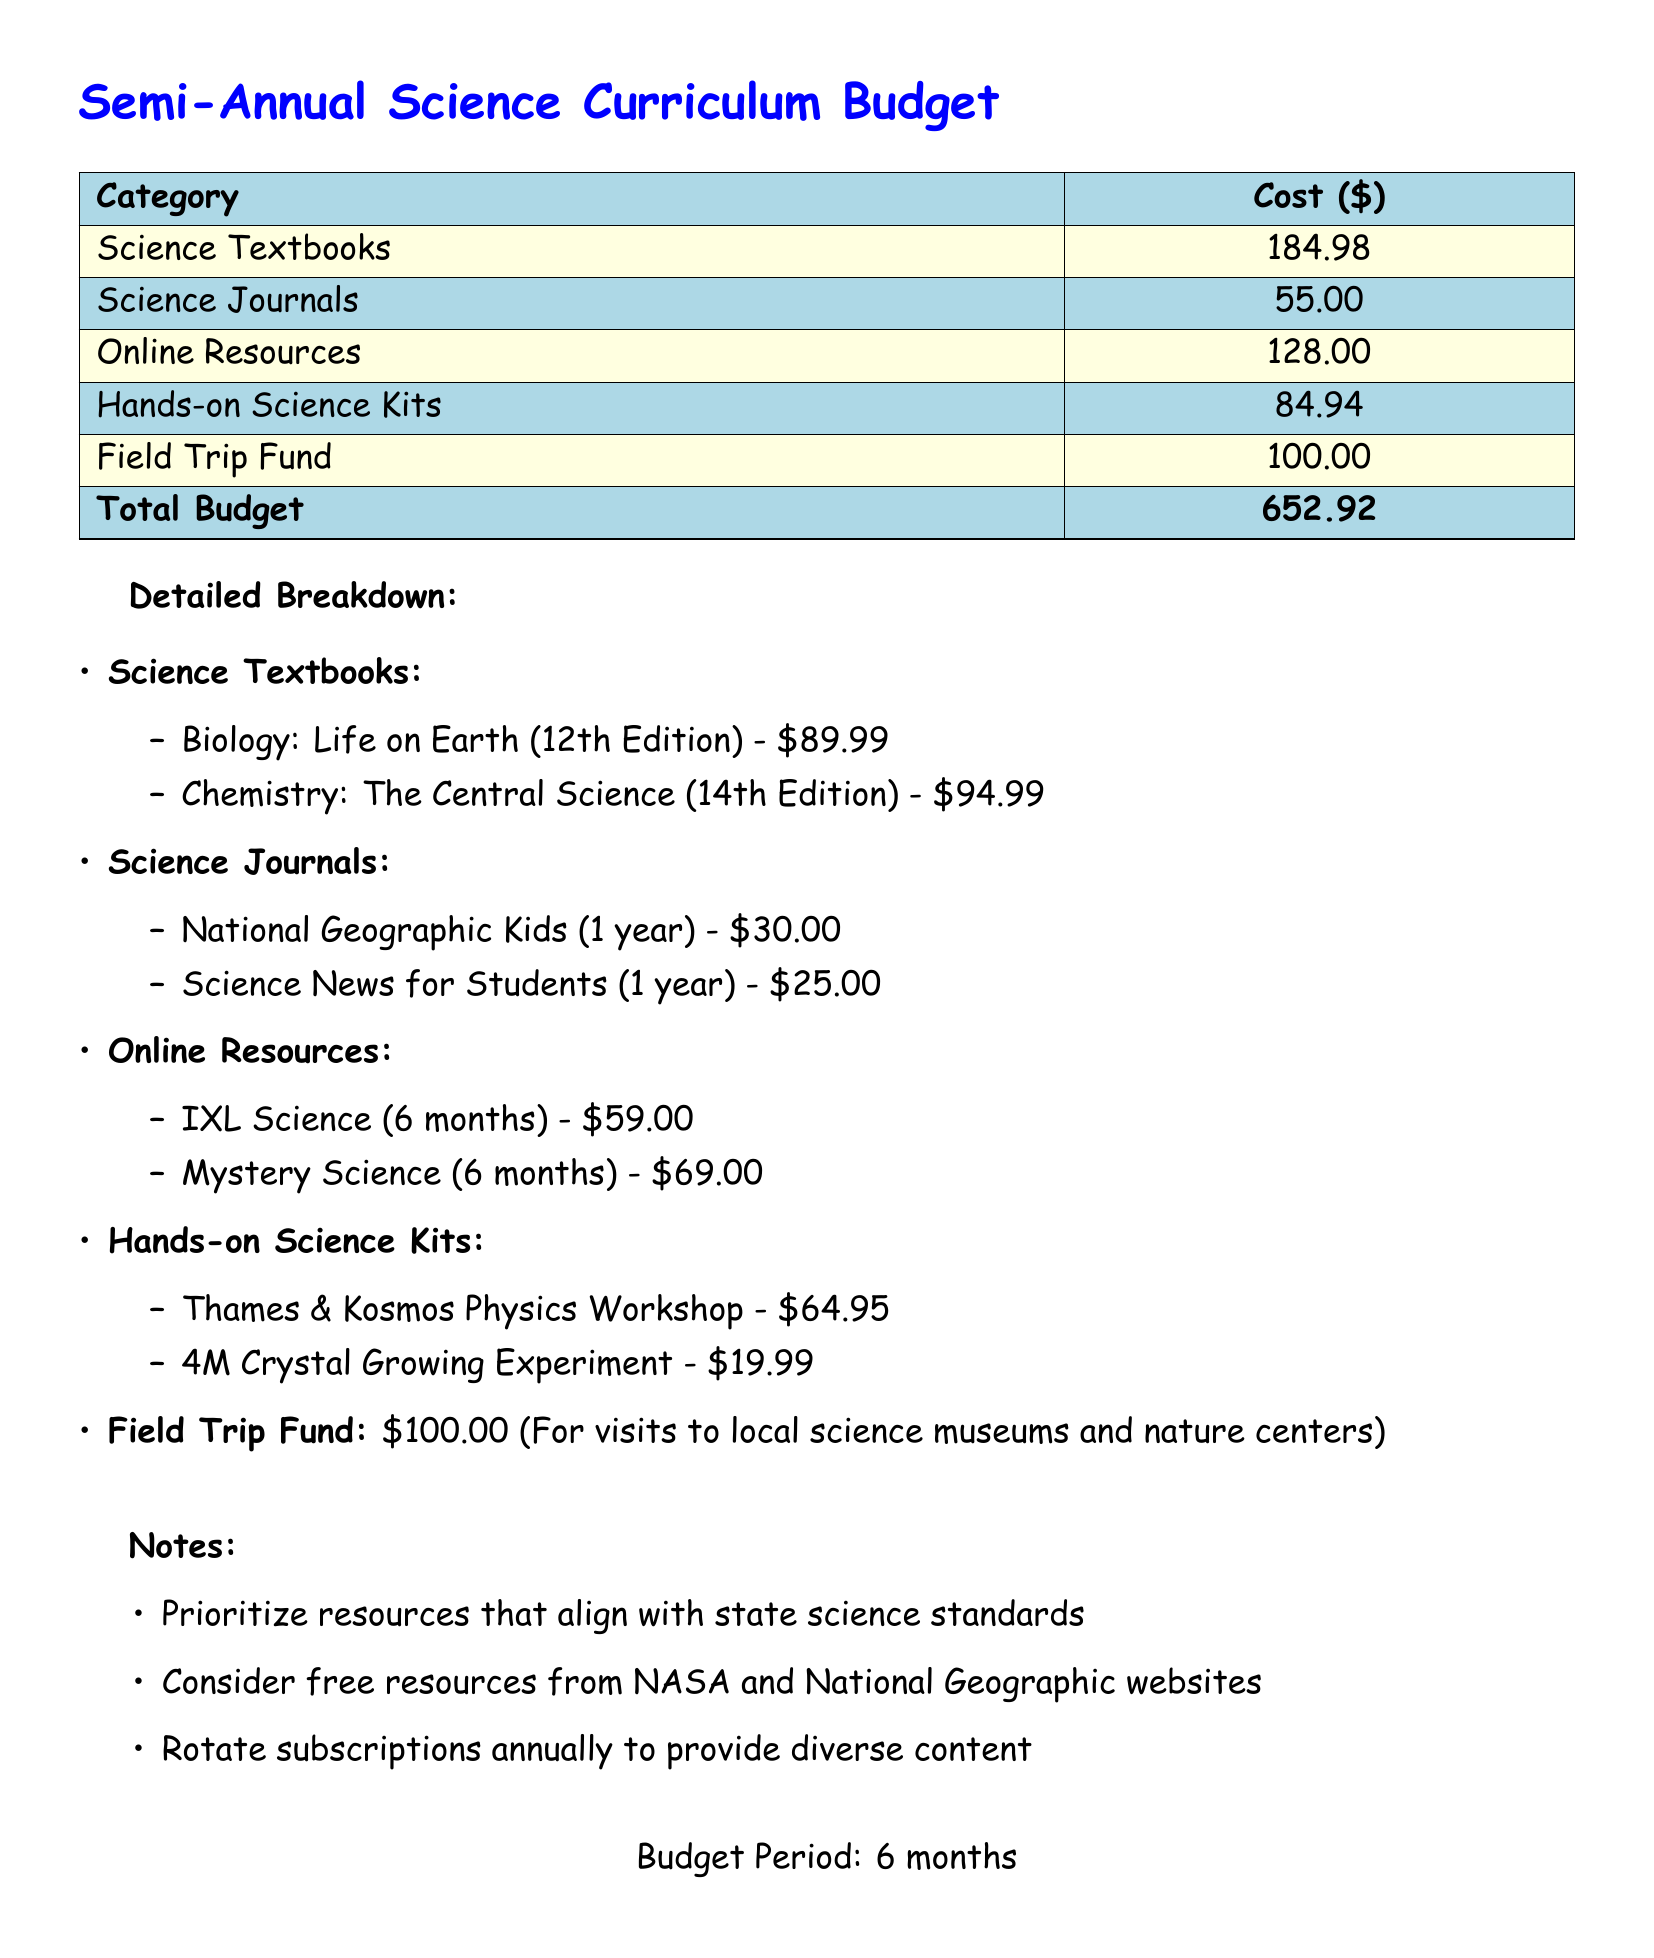What is the total budget? The total budget is the sum of all categories listed in the document.
Answer: 652.92 How much do Science Textbooks cost? The total cost for Science Textbooks is provided at the beginning of the detailed breakdown.
Answer: 184.98 What are the titles of the Biology textbook? The title of the Biology textbook is listed under Science Textbooks in the detailed breakdown.
Answer: Biology: Life on Earth (12th Edition) What is the cost of Science News for Students? The cost for Science News for Students is given in the Science Journals section of the document.
Answer: 25.00 How much is allocated for Online Resources? The total amount for Online Resources is shown in the summarized amounts section of the document.
Answer: 128.00 What is the cost of the Thames & Kosmos Physics Workshop? The specific cost for the Thames & Kosmos Physics Workshop is listed under Hands-on Science Kits.
Answer: 64.95 What is the purpose of the Field Trip Fund? The purpose of the Field Trip Fund is described in the notes section of the document.
Answer: Visits to local science museums and nature centers What are the two online resources mentioned? The two online resources are specified in the Online Resources section, providing titles and costs.
Answer: IXL Science, Mystery Science What should be prioritized according to the notes? The notes section lists priorities that should be considered when selecting resources.
Answer: Resources that align with state science standards How long is the budget period? The budget period is stated at the end of the document.
Answer: 6 months 